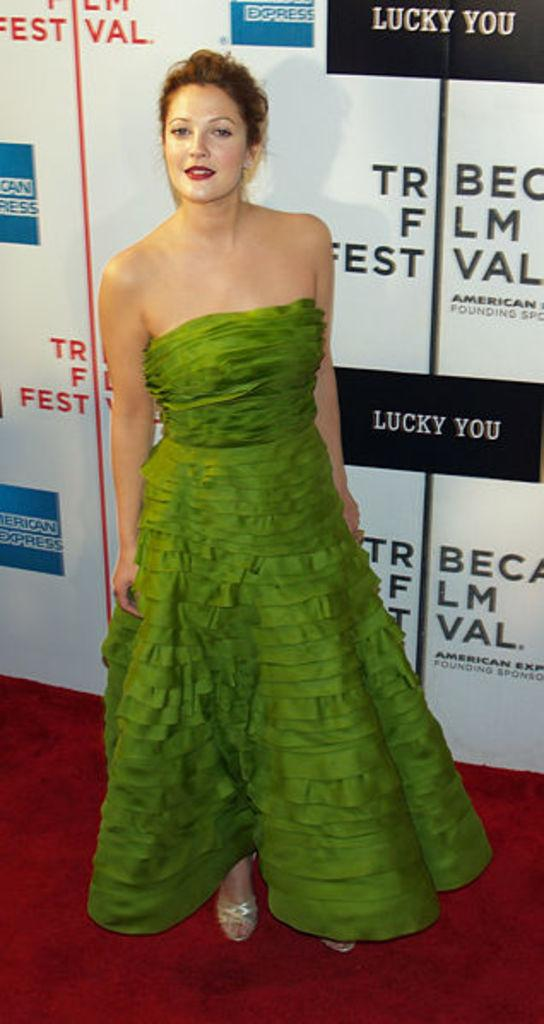Who is the main subject in the foreground of the image? There is a lady standing in the foreground of the image. What can be seen in the background of the image? There is a poster in the background of the image. What is featured on the poster besides the image? There is text on the poster. What type of shoe is the lady wearing in the image? The facts provided do not mention any shoes or footwear, so we cannot determine the type of shoe the lady is wearing. How does the lady's stomach feel in the image? The facts provided do not mention any emotions or physical sensations, so we cannot determine how the lady's stomach feels. 